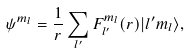<formula> <loc_0><loc_0><loc_500><loc_500>\psi ^ { m _ { l } } = \frac { 1 } { r } \sum _ { l ^ { \prime } } F _ { l ^ { \prime } } ^ { m _ { l } } ( r ) | l ^ { \prime } m _ { l } \rangle ,</formula> 